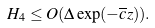Convert formula to latex. <formula><loc_0><loc_0><loc_500><loc_500>H _ { 4 } \leq O ( \Delta \exp ( - \overline { c } z ) ) .</formula> 